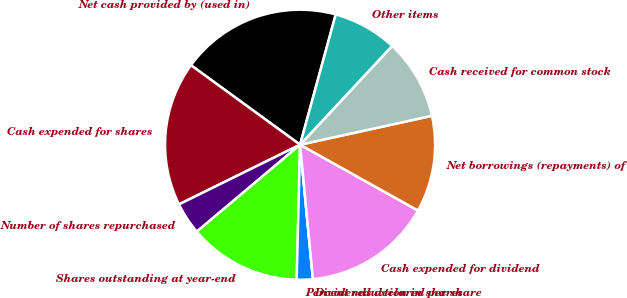Convert chart. <chart><loc_0><loc_0><loc_500><loc_500><pie_chart><fcel>Net cash provided by (used in)<fcel>Cash expended for shares<fcel>Number of shares repurchased<fcel>Shares outstanding at year-end<fcel>Percent reduction in shares<fcel>Dividends declared per share<fcel>Cash expended for dividend<fcel>Net borrowings (repayments) of<fcel>Cash received for common stock<fcel>Other items<nl><fcel>19.23%<fcel>17.31%<fcel>3.85%<fcel>13.46%<fcel>1.92%<fcel>0.0%<fcel>15.38%<fcel>11.54%<fcel>9.62%<fcel>7.69%<nl></chart> 